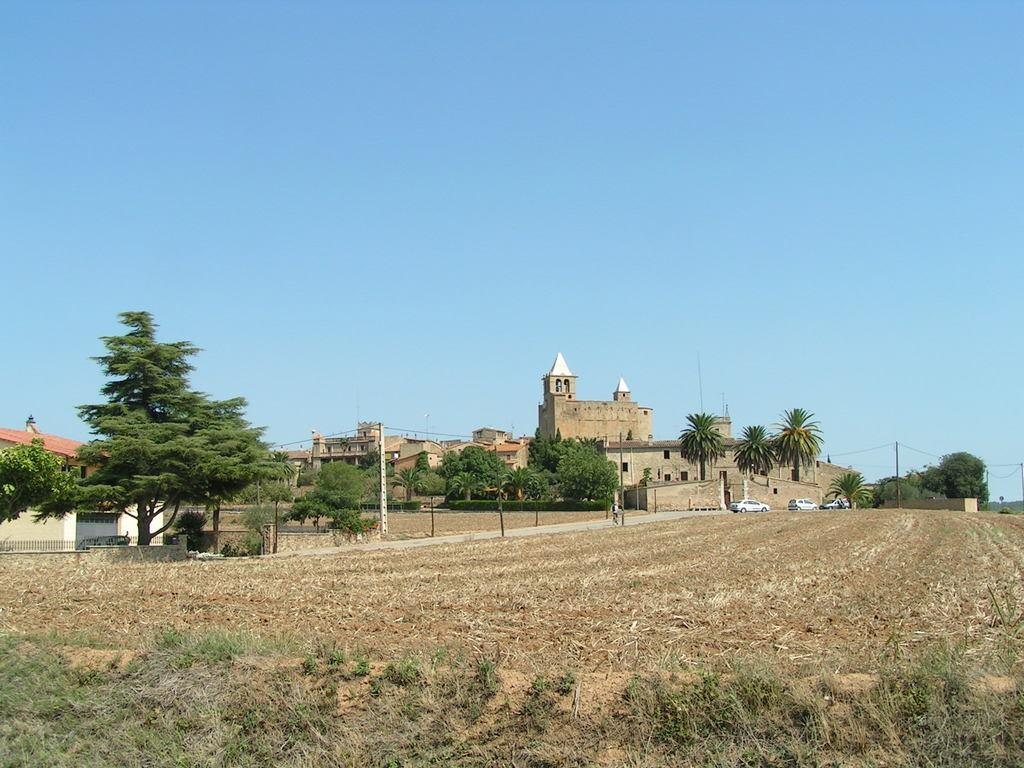What type of landscape is at the bottom of the image? There is a field at the bottom of the image. What natural elements can be seen in the image? There are trees in the image. What man-made structures are present in the image? There are buildings in the image. What vehicles can be seen in the image? There are cars in the image. What is visible in the background of the image? There is a sky visible in the background of the image. What type of chain is being used to plough the field in the image? There is no chain or ploughing activity present in the image; it features a field, trees, buildings, cars, and a sky. 